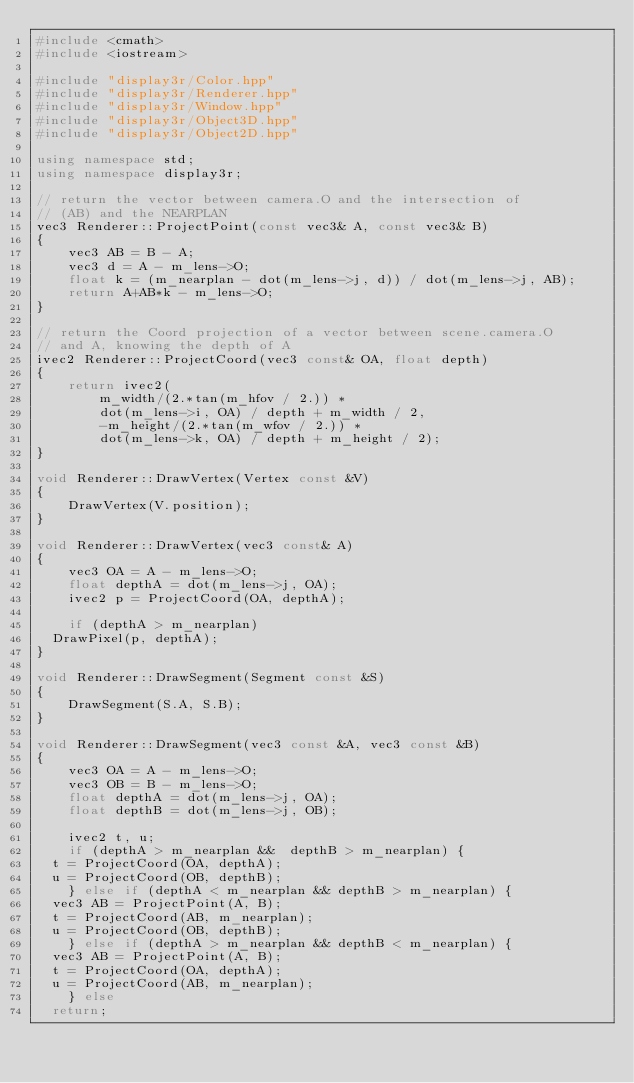<code> <loc_0><loc_0><loc_500><loc_500><_C++_>#include <cmath>
#include <iostream>

#include "display3r/Color.hpp"
#include "display3r/Renderer.hpp"
#include "display3r/Window.hpp"
#include "display3r/Object3D.hpp"
#include "display3r/Object2D.hpp"

using namespace std;
using namespace display3r;

// return the vector between camera.O and the intersection of
// (AB) and the NEARPLAN
vec3 Renderer::ProjectPoint(const vec3& A, const vec3& B)
{
    vec3 AB = B - A;
    vec3 d = A - m_lens->O;
    float k = (m_nearplan - dot(m_lens->j, d)) / dot(m_lens->j, AB);
    return A+AB*k - m_lens->O;
}

// return the Coord projection of a vector between scene.camera.O
// and A, knowing the depth of A
ivec2 Renderer::ProjectCoord(vec3 const& OA, float depth)
{
    return ivec2(
        m_width/(2.*tan(m_hfov / 2.)) *
        dot(m_lens->i, OA) / depth + m_width / 2,
        -m_height/(2.*tan(m_wfov / 2.)) *
        dot(m_lens->k, OA) / depth + m_height / 2);
}

void Renderer::DrawVertex(Vertex const &V)
{
    DrawVertex(V.position);
}

void Renderer::DrawVertex(vec3 const& A)
{
    vec3 OA = A - m_lens->O;
    float depthA = dot(m_lens->j, OA);
    ivec2 p = ProjectCoord(OA, depthA);

    if (depthA > m_nearplan)
	DrawPixel(p, depthA);
}

void Renderer::DrawSegment(Segment const &S)
{
    DrawSegment(S.A, S.B);
}

void Renderer::DrawSegment(vec3 const &A, vec3 const &B)
{
    vec3 OA = A - m_lens->O;
    vec3 OB = B - m_lens->O;
    float depthA = dot(m_lens->j, OA);
    float depthB = dot(m_lens->j, OB);

    ivec2 t, u;
    if (depthA > m_nearplan &&  depthB > m_nearplan) {
	t = ProjectCoord(OA, depthA);
	u = ProjectCoord(OB, depthB);
    } else if (depthA < m_nearplan && depthB > m_nearplan) {
	vec3 AB = ProjectPoint(A, B);
	t = ProjectCoord(AB, m_nearplan);
	u = ProjectCoord(OB, depthB);
    } else if (depthA > m_nearplan && depthB < m_nearplan) {
	vec3 AB = ProjectPoint(A, B);
	t = ProjectCoord(OA, depthA);
	u = ProjectCoord(AB, m_nearplan);
    } else
	return;
</code> 